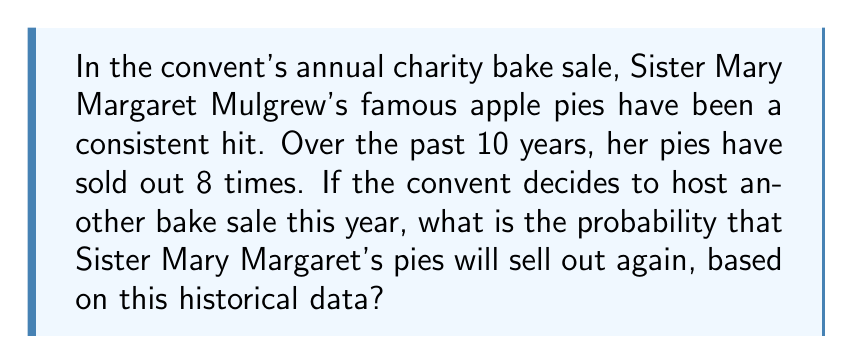Solve this math problem. To solve this problem, we need to use the concept of relative frequency as an estimate of probability. The relative frequency of an event is calculated by dividing the number of times the event occurred by the total number of trials.

Let's define our variables:
$n$ = number of times the event occurred (pies sold out)
$N$ = total number of trials (years of data)

In this case:
$n = 8$ (pies sold out 8 times)
$N = 10$ (10 years of data)

The probability estimate is given by the formula:

$$P(\text{event}) = \frac{n}{N}$$

Substituting our values:

$$P(\text{pies sell out}) = \frac{8}{10} = 0.8$$

This can also be expressed as a percentage:

$$0.8 \times 100\% = 80\%$$

It's important to note that this is an estimate based on historical data and assumes that past performance is indicative of future results. In reality, other factors could influence the outcome, such as changes in the recipe, variations in attendance, or competing baked goods.
Answer: The probability that Sister Mary Margaret's pies will sell out in the next bake sale, based on historical data, is $0.8$ or $80\%$. 